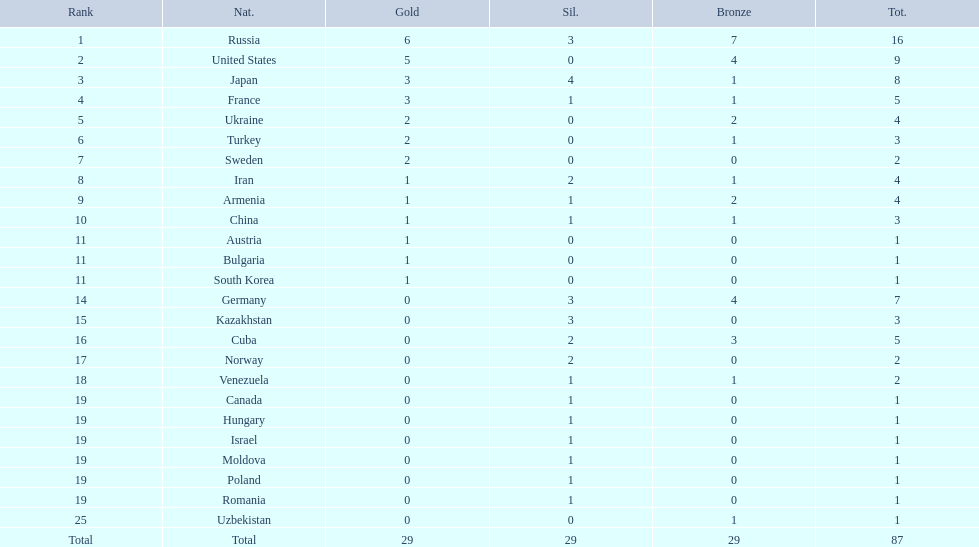Which nations have gold medals? Russia, United States, Japan, France, Ukraine, Turkey, Sweden, Iran, Armenia, China, Austria, Bulgaria, South Korea. Of those nations, which have only one gold medal? Iran, Armenia, China, Austria, Bulgaria, South Korea. Of those nations, which has no bronze or silver medals? Austria. 